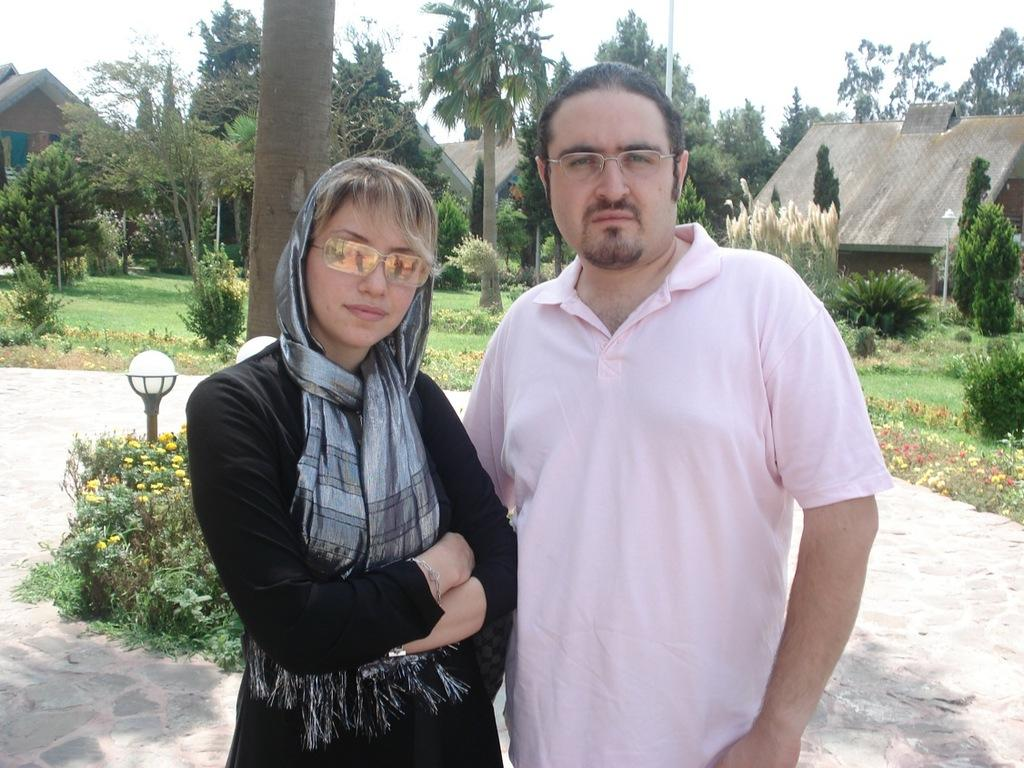Who are the two people in the center of the image? There is a woman and a man standing in the center of the image. What is the surface they are standing on? They are standing on the ground. What can be seen in the background of the image? There are flowers, plants, lights, trees, houses, and the sky visible in the background of the image. Is there a jail visible in the image? No, there is no jail present in the image. Does the existence of the woman and man in the image prove the existence of extraterrestrial life? No, the presence of the woman and man in the image does not prove the existence of extraterrestrial life. 